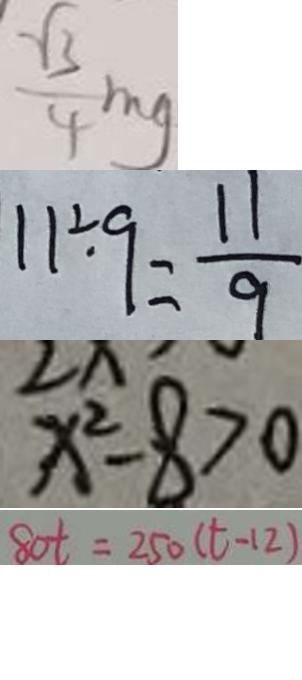Convert formula to latex. <formula><loc_0><loc_0><loc_500><loc_500>\frac { \sqrt { 3 } } { 4 } m g 
 1 1 \div 9 = \frac { 1 1 } { 9 } 
 x ^ { 2 } - 8 > 0 
 8 0 t = 2 5 0 ( t - 1 2 )</formula> 